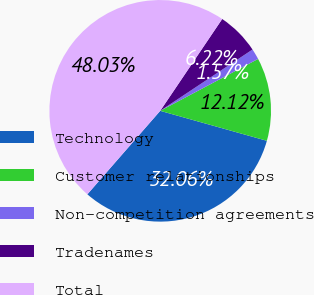<chart> <loc_0><loc_0><loc_500><loc_500><pie_chart><fcel>Technology<fcel>Customer relationships<fcel>Non-competition agreements<fcel>Tradenames<fcel>Total<nl><fcel>32.06%<fcel>12.12%<fcel>1.57%<fcel>6.22%<fcel>48.03%<nl></chart> 